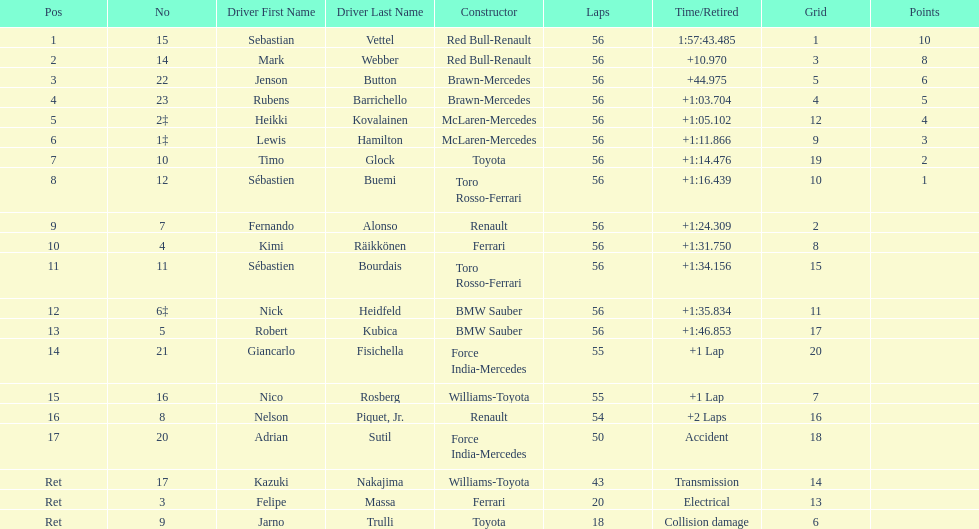Which driver is the only driver who retired because of collision damage? Jarno Trulli. 